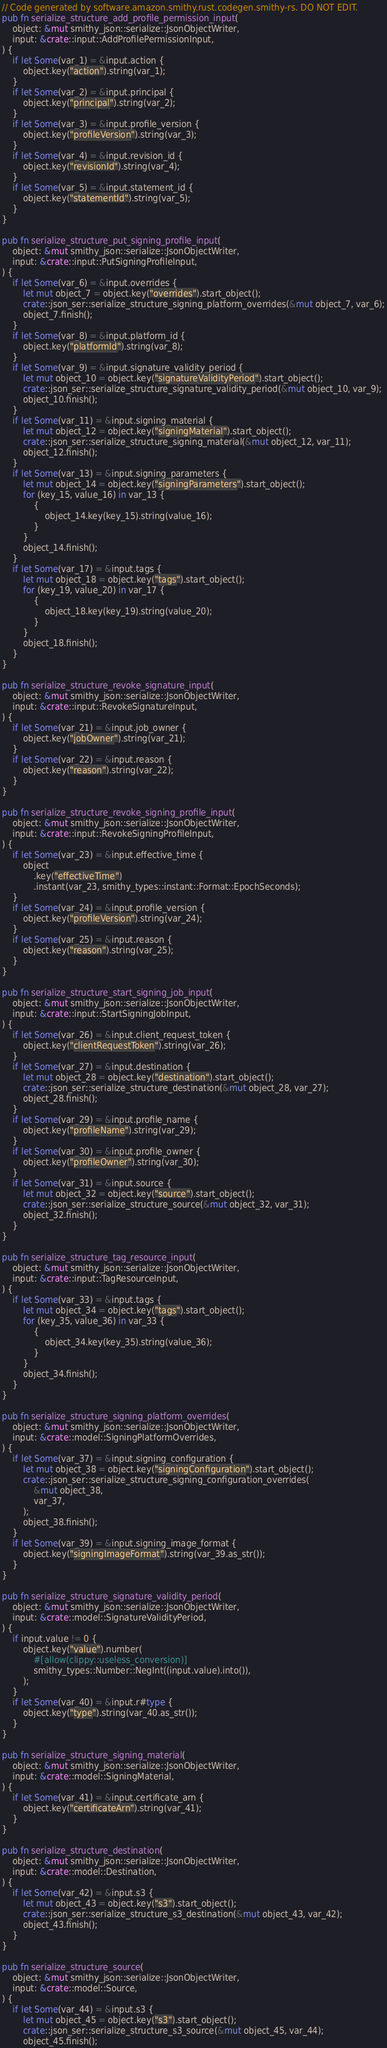Convert code to text. <code><loc_0><loc_0><loc_500><loc_500><_Rust_>// Code generated by software.amazon.smithy.rust.codegen.smithy-rs. DO NOT EDIT.
pub fn serialize_structure_add_profile_permission_input(
    object: &mut smithy_json::serialize::JsonObjectWriter,
    input: &crate::input::AddProfilePermissionInput,
) {
    if let Some(var_1) = &input.action {
        object.key("action").string(var_1);
    }
    if let Some(var_2) = &input.principal {
        object.key("principal").string(var_2);
    }
    if let Some(var_3) = &input.profile_version {
        object.key("profileVersion").string(var_3);
    }
    if let Some(var_4) = &input.revision_id {
        object.key("revisionId").string(var_4);
    }
    if let Some(var_5) = &input.statement_id {
        object.key("statementId").string(var_5);
    }
}

pub fn serialize_structure_put_signing_profile_input(
    object: &mut smithy_json::serialize::JsonObjectWriter,
    input: &crate::input::PutSigningProfileInput,
) {
    if let Some(var_6) = &input.overrides {
        let mut object_7 = object.key("overrides").start_object();
        crate::json_ser::serialize_structure_signing_platform_overrides(&mut object_7, var_6);
        object_7.finish();
    }
    if let Some(var_8) = &input.platform_id {
        object.key("platformId").string(var_8);
    }
    if let Some(var_9) = &input.signature_validity_period {
        let mut object_10 = object.key("signatureValidityPeriod").start_object();
        crate::json_ser::serialize_structure_signature_validity_period(&mut object_10, var_9);
        object_10.finish();
    }
    if let Some(var_11) = &input.signing_material {
        let mut object_12 = object.key("signingMaterial").start_object();
        crate::json_ser::serialize_structure_signing_material(&mut object_12, var_11);
        object_12.finish();
    }
    if let Some(var_13) = &input.signing_parameters {
        let mut object_14 = object.key("signingParameters").start_object();
        for (key_15, value_16) in var_13 {
            {
                object_14.key(key_15).string(value_16);
            }
        }
        object_14.finish();
    }
    if let Some(var_17) = &input.tags {
        let mut object_18 = object.key("tags").start_object();
        for (key_19, value_20) in var_17 {
            {
                object_18.key(key_19).string(value_20);
            }
        }
        object_18.finish();
    }
}

pub fn serialize_structure_revoke_signature_input(
    object: &mut smithy_json::serialize::JsonObjectWriter,
    input: &crate::input::RevokeSignatureInput,
) {
    if let Some(var_21) = &input.job_owner {
        object.key("jobOwner").string(var_21);
    }
    if let Some(var_22) = &input.reason {
        object.key("reason").string(var_22);
    }
}

pub fn serialize_structure_revoke_signing_profile_input(
    object: &mut smithy_json::serialize::JsonObjectWriter,
    input: &crate::input::RevokeSigningProfileInput,
) {
    if let Some(var_23) = &input.effective_time {
        object
            .key("effectiveTime")
            .instant(var_23, smithy_types::instant::Format::EpochSeconds);
    }
    if let Some(var_24) = &input.profile_version {
        object.key("profileVersion").string(var_24);
    }
    if let Some(var_25) = &input.reason {
        object.key("reason").string(var_25);
    }
}

pub fn serialize_structure_start_signing_job_input(
    object: &mut smithy_json::serialize::JsonObjectWriter,
    input: &crate::input::StartSigningJobInput,
) {
    if let Some(var_26) = &input.client_request_token {
        object.key("clientRequestToken").string(var_26);
    }
    if let Some(var_27) = &input.destination {
        let mut object_28 = object.key("destination").start_object();
        crate::json_ser::serialize_structure_destination(&mut object_28, var_27);
        object_28.finish();
    }
    if let Some(var_29) = &input.profile_name {
        object.key("profileName").string(var_29);
    }
    if let Some(var_30) = &input.profile_owner {
        object.key("profileOwner").string(var_30);
    }
    if let Some(var_31) = &input.source {
        let mut object_32 = object.key("source").start_object();
        crate::json_ser::serialize_structure_source(&mut object_32, var_31);
        object_32.finish();
    }
}

pub fn serialize_structure_tag_resource_input(
    object: &mut smithy_json::serialize::JsonObjectWriter,
    input: &crate::input::TagResourceInput,
) {
    if let Some(var_33) = &input.tags {
        let mut object_34 = object.key("tags").start_object();
        for (key_35, value_36) in var_33 {
            {
                object_34.key(key_35).string(value_36);
            }
        }
        object_34.finish();
    }
}

pub fn serialize_structure_signing_platform_overrides(
    object: &mut smithy_json::serialize::JsonObjectWriter,
    input: &crate::model::SigningPlatformOverrides,
) {
    if let Some(var_37) = &input.signing_configuration {
        let mut object_38 = object.key("signingConfiguration").start_object();
        crate::json_ser::serialize_structure_signing_configuration_overrides(
            &mut object_38,
            var_37,
        );
        object_38.finish();
    }
    if let Some(var_39) = &input.signing_image_format {
        object.key("signingImageFormat").string(var_39.as_str());
    }
}

pub fn serialize_structure_signature_validity_period(
    object: &mut smithy_json::serialize::JsonObjectWriter,
    input: &crate::model::SignatureValidityPeriod,
) {
    if input.value != 0 {
        object.key("value").number(
            #[allow(clippy::useless_conversion)]
            smithy_types::Number::NegInt((input.value).into()),
        );
    }
    if let Some(var_40) = &input.r#type {
        object.key("type").string(var_40.as_str());
    }
}

pub fn serialize_structure_signing_material(
    object: &mut smithy_json::serialize::JsonObjectWriter,
    input: &crate::model::SigningMaterial,
) {
    if let Some(var_41) = &input.certificate_arn {
        object.key("certificateArn").string(var_41);
    }
}

pub fn serialize_structure_destination(
    object: &mut smithy_json::serialize::JsonObjectWriter,
    input: &crate::model::Destination,
) {
    if let Some(var_42) = &input.s3 {
        let mut object_43 = object.key("s3").start_object();
        crate::json_ser::serialize_structure_s3_destination(&mut object_43, var_42);
        object_43.finish();
    }
}

pub fn serialize_structure_source(
    object: &mut smithy_json::serialize::JsonObjectWriter,
    input: &crate::model::Source,
) {
    if let Some(var_44) = &input.s3 {
        let mut object_45 = object.key("s3").start_object();
        crate::json_ser::serialize_structure_s3_source(&mut object_45, var_44);
        object_45.finish();</code> 